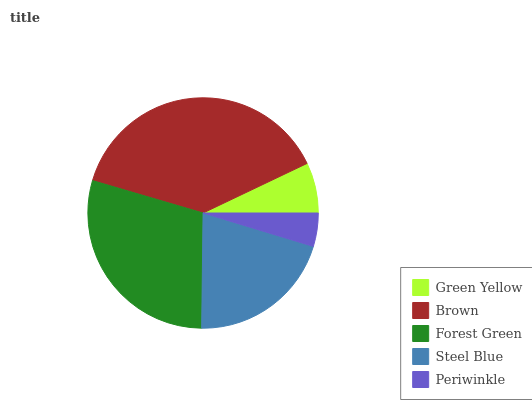Is Periwinkle the minimum?
Answer yes or no. Yes. Is Brown the maximum?
Answer yes or no. Yes. Is Forest Green the minimum?
Answer yes or no. No. Is Forest Green the maximum?
Answer yes or no. No. Is Brown greater than Forest Green?
Answer yes or no. Yes. Is Forest Green less than Brown?
Answer yes or no. Yes. Is Forest Green greater than Brown?
Answer yes or no. No. Is Brown less than Forest Green?
Answer yes or no. No. Is Steel Blue the high median?
Answer yes or no. Yes. Is Steel Blue the low median?
Answer yes or no. Yes. Is Green Yellow the high median?
Answer yes or no. No. Is Green Yellow the low median?
Answer yes or no. No. 